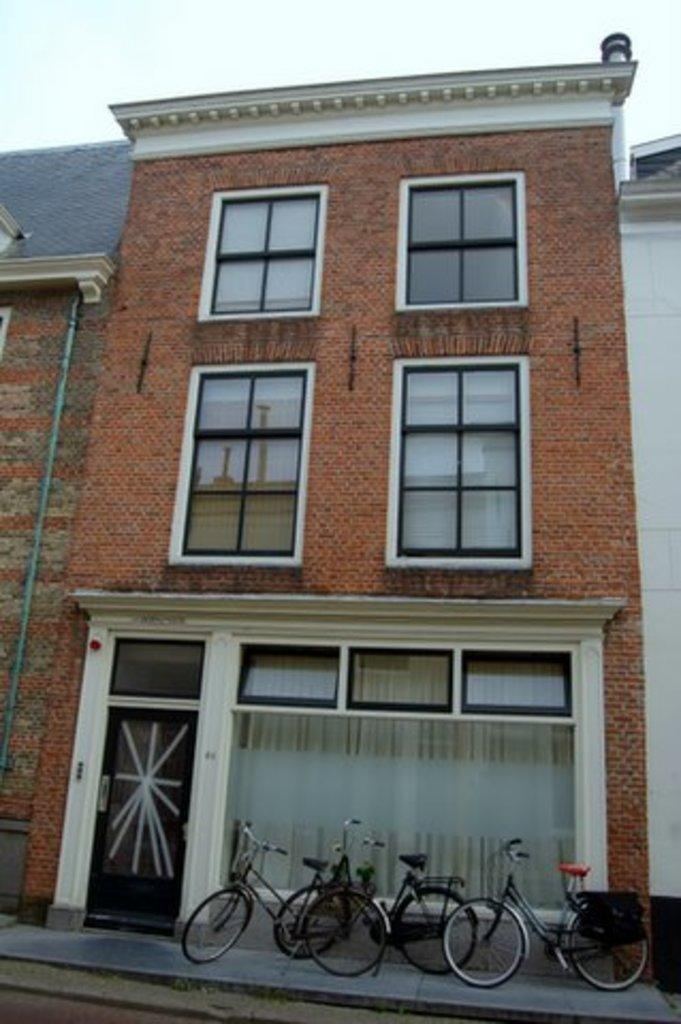What type of structure is present in the image? There is a building in the image. What feature can be seen on the building? There are windows in the building. What mode of transportation is visible in the image? There are bicycles in the image. What is visible in the background of the image? The sky is visible in the image. What type of alarm can be heard going off in the image? There is no alarm present in the image, and therefore no sound can be heard. What type of frame is holding the bicycles in the image? There is no frame holding the bicycles in the image; they are simply visible on the ground or against the building. 